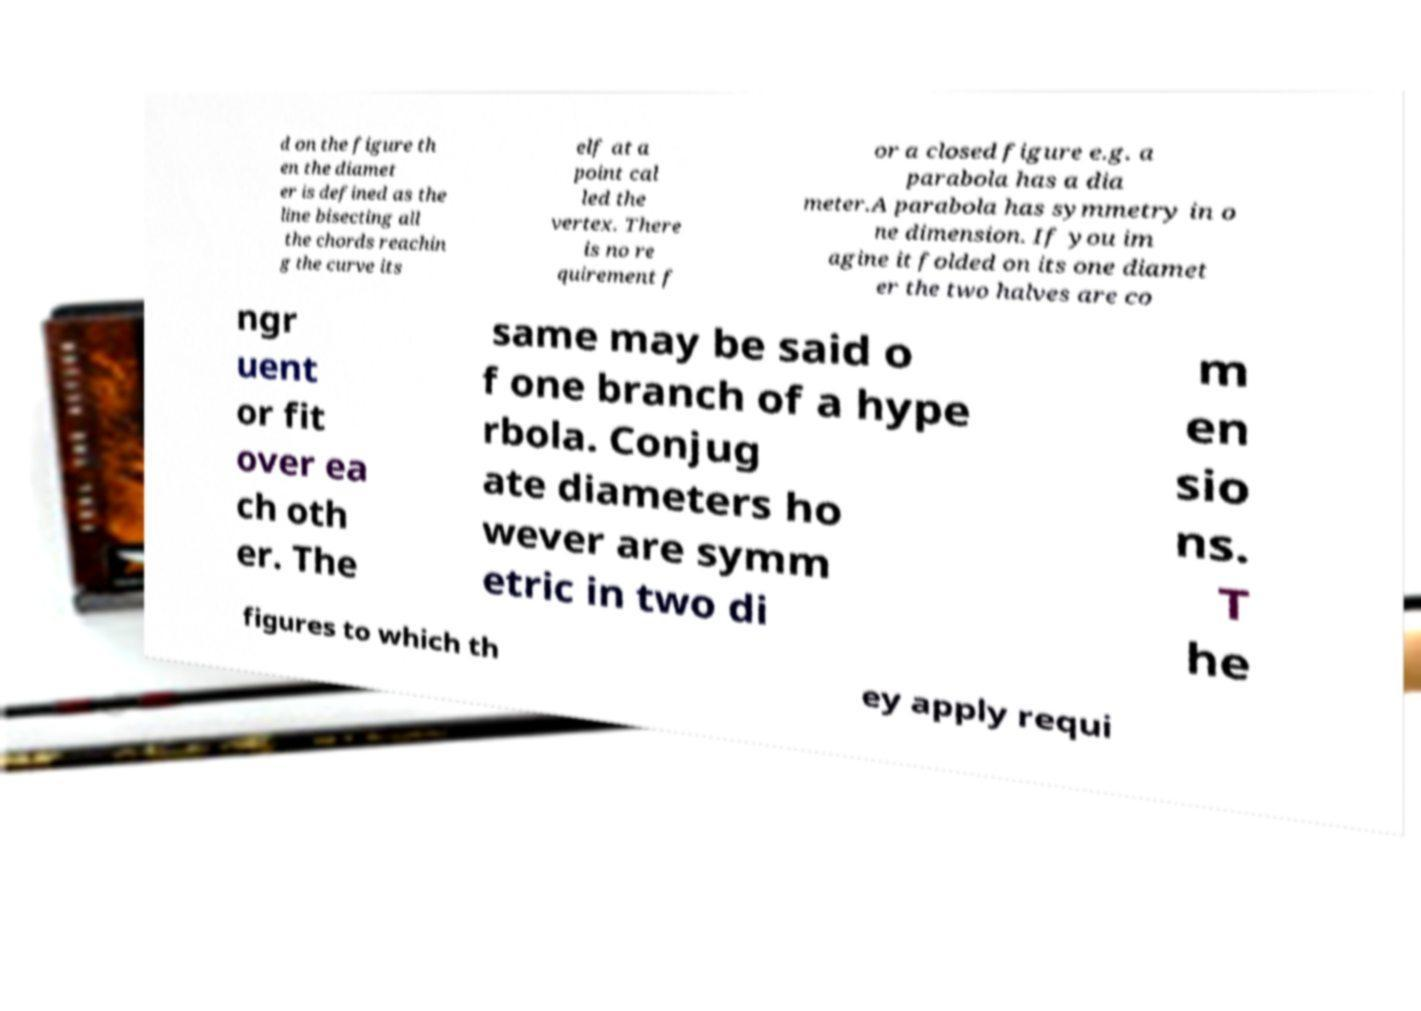Can you accurately transcribe the text from the provided image for me? d on the figure th en the diamet er is defined as the line bisecting all the chords reachin g the curve its elf at a point cal led the vertex. There is no re quirement f or a closed figure e.g. a parabola has a dia meter.A parabola has symmetry in o ne dimension. If you im agine it folded on its one diamet er the two halves are co ngr uent or fit over ea ch oth er. The same may be said o f one branch of a hype rbola. Conjug ate diameters ho wever are symm etric in two di m en sio ns. T he figures to which th ey apply requi 